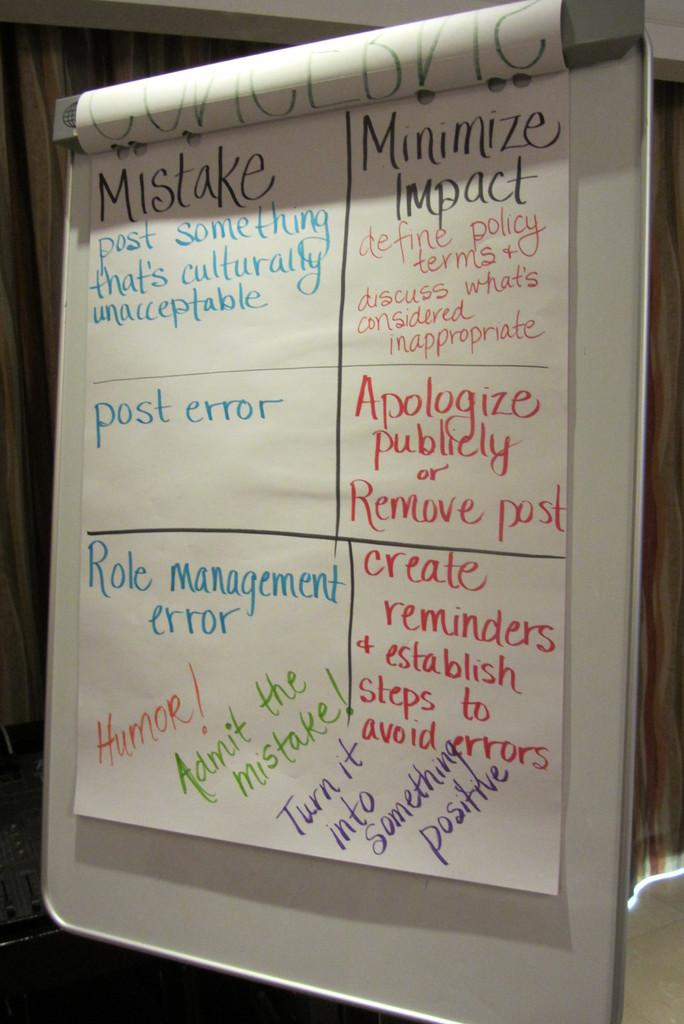<image>
Write a terse but informative summary of the picture. The square on the white sheet of paper says Apologize publicly or remove post. 